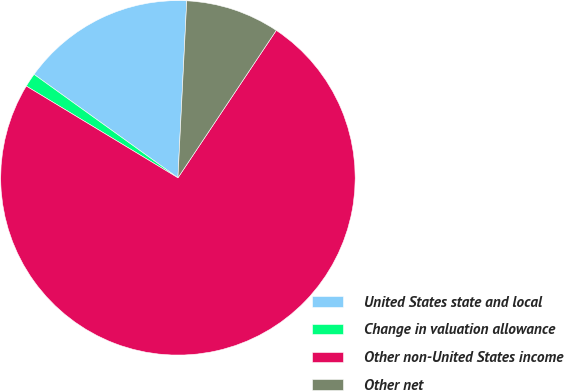Convert chart to OTSL. <chart><loc_0><loc_0><loc_500><loc_500><pie_chart><fcel>United States state and local<fcel>Change in valuation allowance<fcel>Other non-United States income<fcel>Other net<nl><fcel>15.87%<fcel>1.26%<fcel>74.3%<fcel>8.57%<nl></chart> 